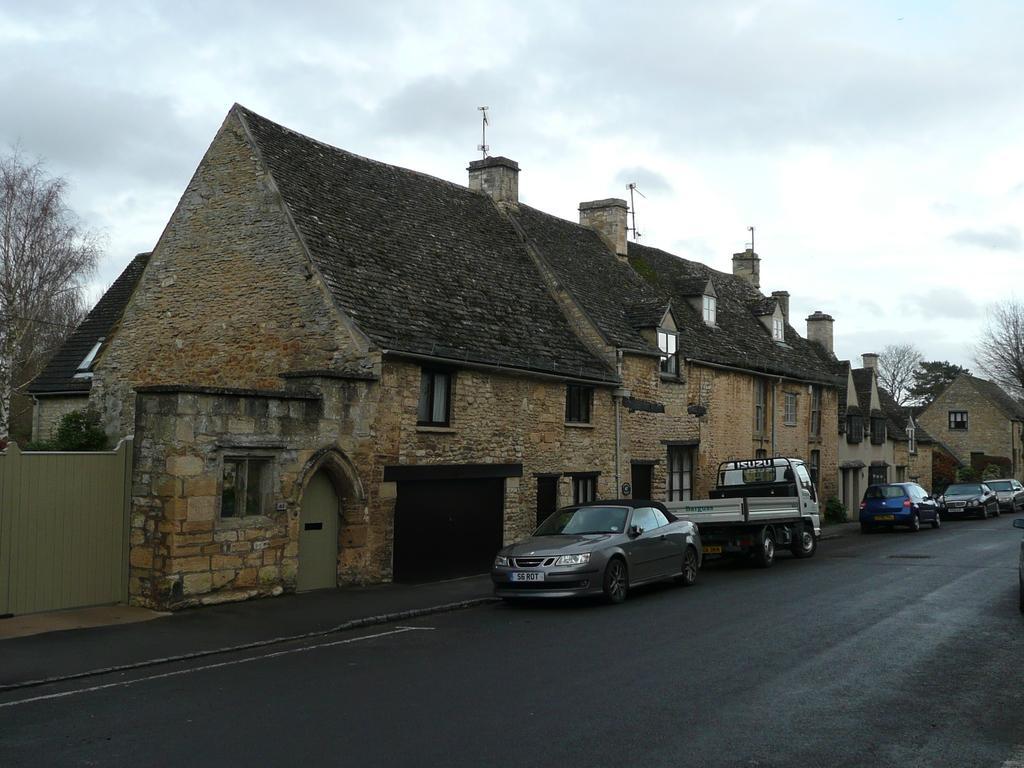In one or two sentences, can you explain what this image depicts? In this picture we can see few vehicles on the road, beside to the vehicles we can find few buildings, in the background we can see few trees and clouds, on the left side of the image we can find a door. 